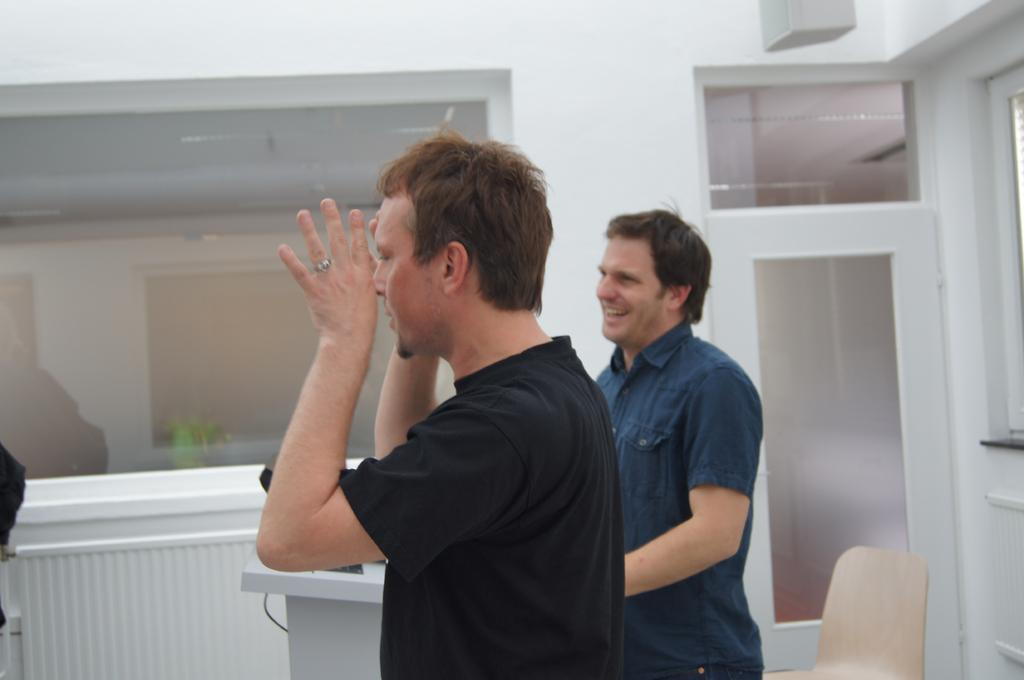How many people are in the center of the image? There are two men standing in the center of the image. What objects can be seen in the background of the image? There is a glass, a wall, a door, a chair, a roof, a podium, a laptop, wires, and a person's hand in the background of the image. How far away is the thunder from the people in the image? There is no thunder present in the image, so it cannot be determined how far away it is from the people. 